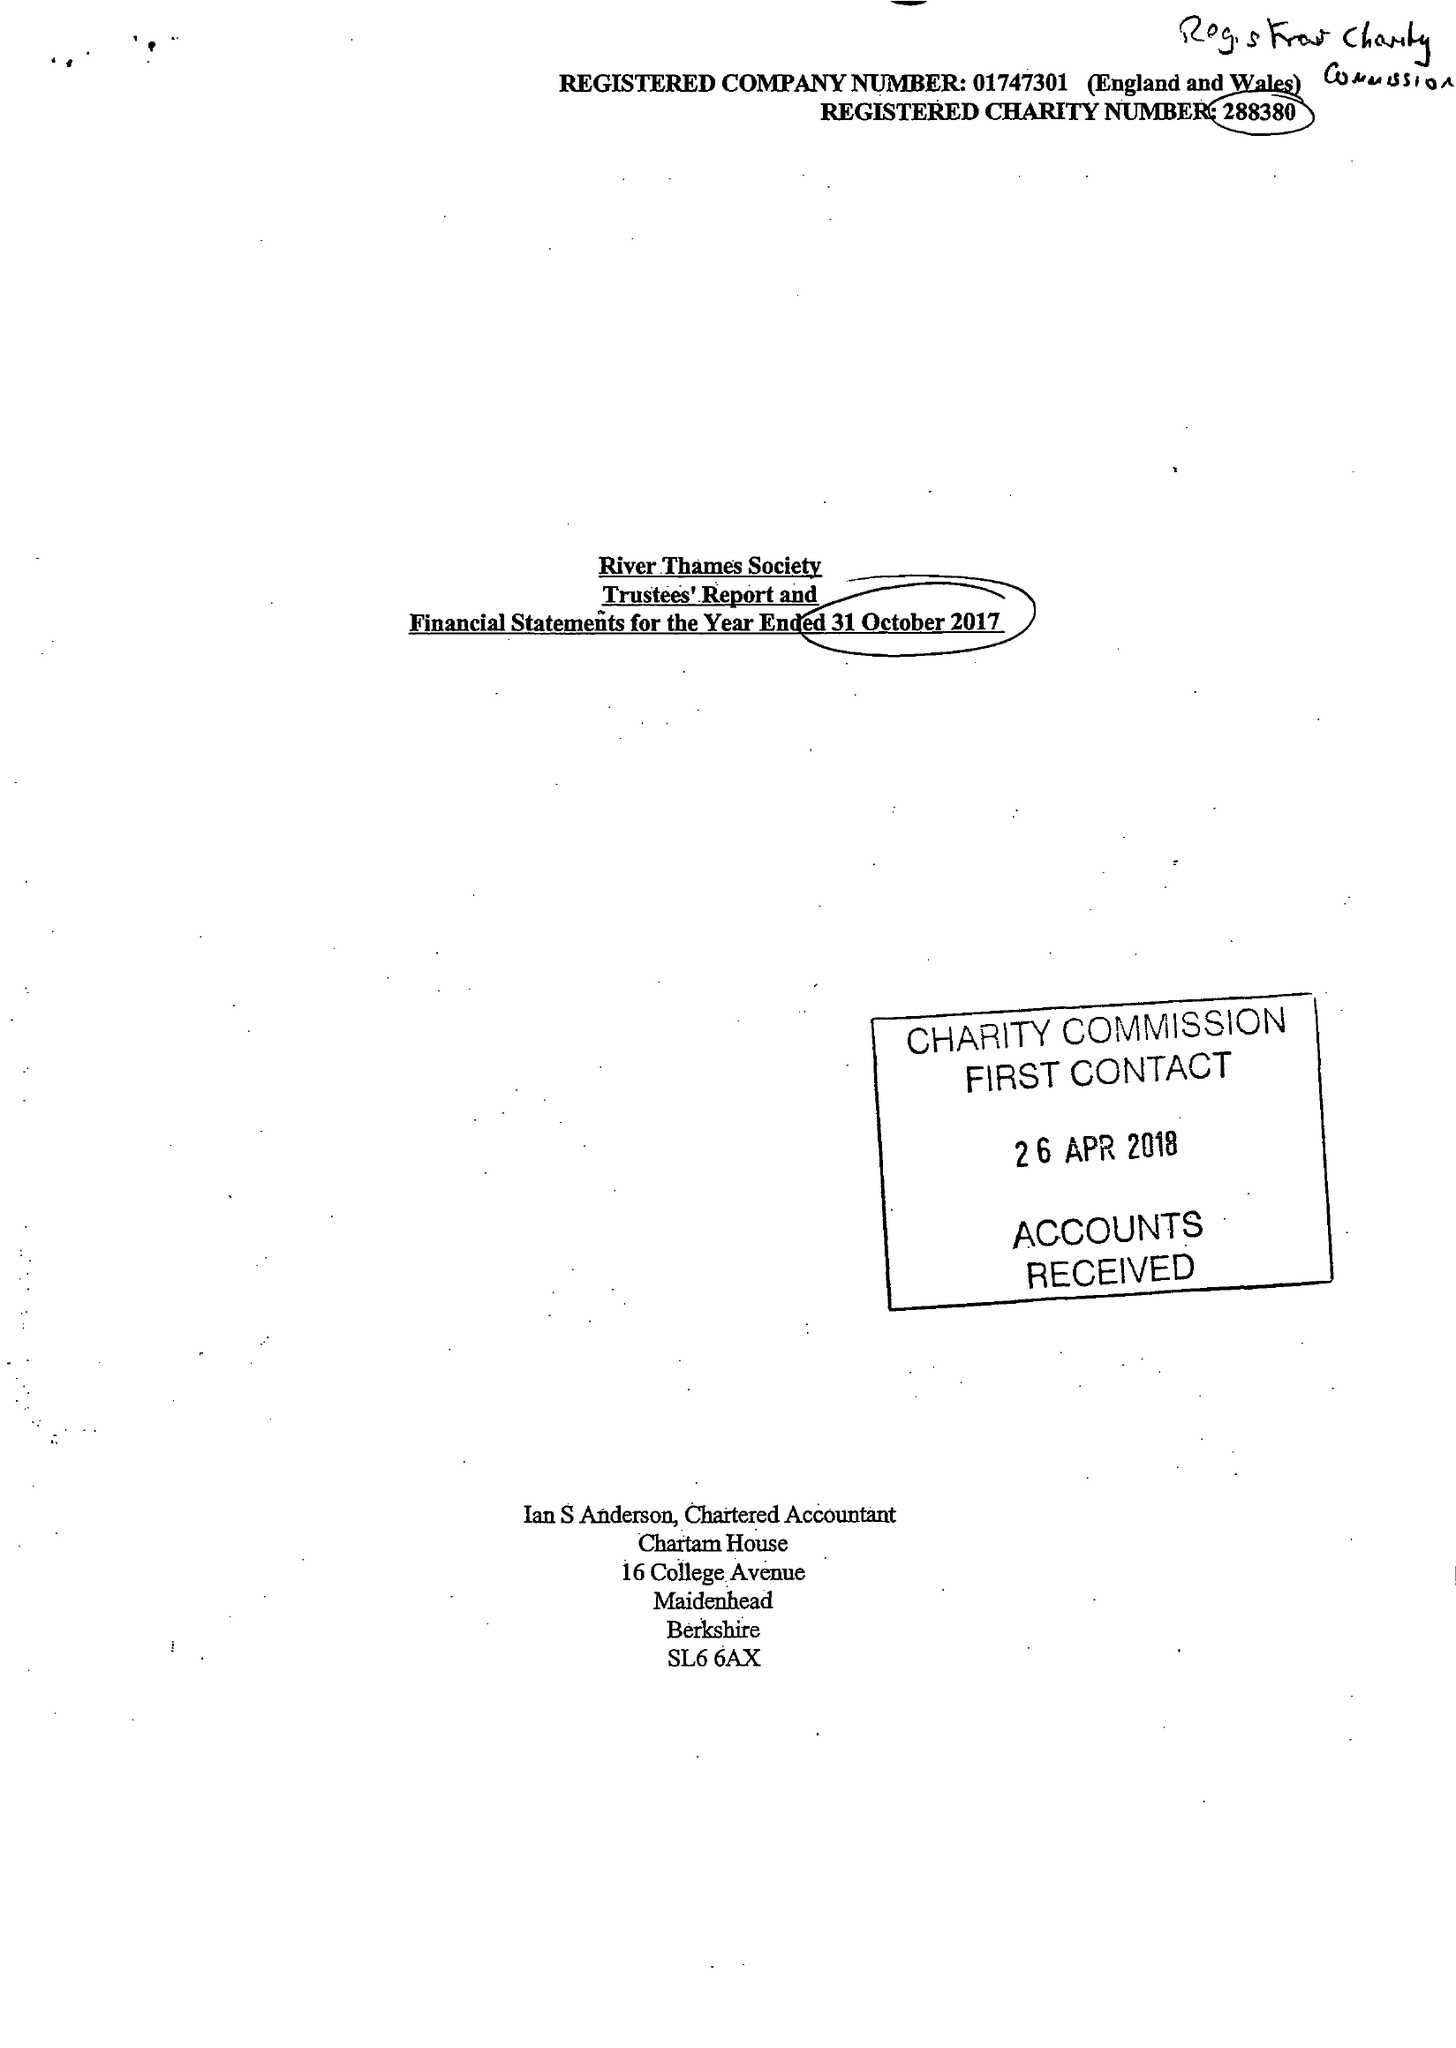What is the value for the income_annually_in_british_pounds?
Answer the question using a single word or phrase. 37343.00 